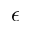Convert formula to latex. <formula><loc_0><loc_0><loc_500><loc_500>\epsilon</formula> 